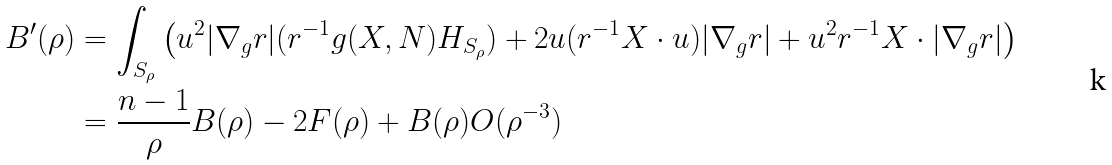<formula> <loc_0><loc_0><loc_500><loc_500>B ^ { \prime } ( \rho ) & = \int _ { S _ { \rho } } \left ( u ^ { 2 } | \nabla _ { g } r | ( r ^ { - 1 } g ( X , N ) H _ { S _ { \rho } } ) + 2 u ( r ^ { - 1 } X \cdot u ) | \nabla _ { g } r | + u ^ { 2 } r ^ { - 1 } X \cdot | \nabla _ { g } r | \right ) \\ & = \frac { n - 1 } { \rho } B ( \rho ) - 2 F ( \rho ) + B ( \rho ) O ( \rho ^ { - 3 } )</formula> 